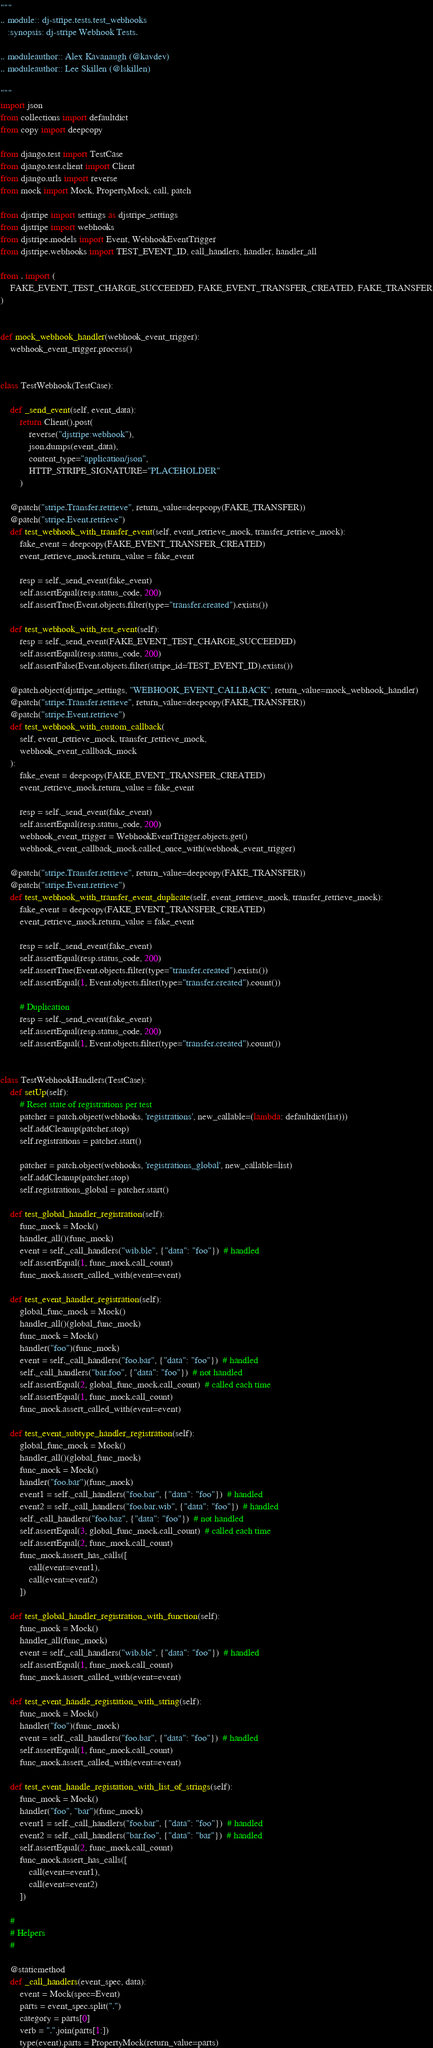Convert code to text. <code><loc_0><loc_0><loc_500><loc_500><_Python_>"""
.. module:: dj-stripe.tests.test_webhooks
   :synopsis: dj-stripe Webhook Tests.

.. moduleauthor:: Alex Kavanaugh (@kavdev)
.. moduleauthor:: Lee Skillen (@lskillen)

"""
import json
from collections import defaultdict
from copy import deepcopy

from django.test import TestCase
from django.test.client import Client
from django.urls import reverse
from mock import Mock, PropertyMock, call, patch

from djstripe import settings as djstripe_settings
from djstripe import webhooks
from djstripe.models import Event, WebhookEventTrigger
from djstripe.webhooks import TEST_EVENT_ID, call_handlers, handler, handler_all

from . import (
    FAKE_EVENT_TEST_CHARGE_SUCCEEDED, FAKE_EVENT_TRANSFER_CREATED, FAKE_TRANSFER
)


def mock_webhook_handler(webhook_event_trigger):
    webhook_event_trigger.process()


class TestWebhook(TestCase):

    def _send_event(self, event_data):
        return Client().post(
            reverse("djstripe:webhook"),
            json.dumps(event_data),
            content_type="application/json",
            HTTP_STRIPE_SIGNATURE="PLACEHOLDER"
        )

    @patch("stripe.Transfer.retrieve", return_value=deepcopy(FAKE_TRANSFER))
    @patch("stripe.Event.retrieve")
    def test_webhook_with_transfer_event(self, event_retrieve_mock, transfer_retrieve_mock):
        fake_event = deepcopy(FAKE_EVENT_TRANSFER_CREATED)
        event_retrieve_mock.return_value = fake_event

        resp = self._send_event(fake_event)
        self.assertEqual(resp.status_code, 200)
        self.assertTrue(Event.objects.filter(type="transfer.created").exists())

    def test_webhook_with_test_event(self):
        resp = self._send_event(FAKE_EVENT_TEST_CHARGE_SUCCEEDED)
        self.assertEqual(resp.status_code, 200)
        self.assertFalse(Event.objects.filter(stripe_id=TEST_EVENT_ID).exists())

    @patch.object(djstripe_settings, "WEBHOOK_EVENT_CALLBACK", return_value=mock_webhook_handler)
    @patch("stripe.Transfer.retrieve", return_value=deepcopy(FAKE_TRANSFER))
    @patch("stripe.Event.retrieve")
    def test_webhook_with_custom_callback(
        self, event_retrieve_mock, transfer_retrieve_mock,
        webhook_event_callback_mock
    ):
        fake_event = deepcopy(FAKE_EVENT_TRANSFER_CREATED)
        event_retrieve_mock.return_value = fake_event

        resp = self._send_event(fake_event)
        self.assertEqual(resp.status_code, 200)
        webhook_event_trigger = WebhookEventTrigger.objects.get()
        webhook_event_callback_mock.called_once_with(webhook_event_trigger)

    @patch("stripe.Transfer.retrieve", return_value=deepcopy(FAKE_TRANSFER))
    @patch("stripe.Event.retrieve")
    def test_webhook_with_transfer_event_duplicate(self, event_retrieve_mock, transfer_retrieve_mock):
        fake_event = deepcopy(FAKE_EVENT_TRANSFER_CREATED)
        event_retrieve_mock.return_value = fake_event

        resp = self._send_event(fake_event)
        self.assertEqual(resp.status_code, 200)
        self.assertTrue(Event.objects.filter(type="transfer.created").exists())
        self.assertEqual(1, Event.objects.filter(type="transfer.created").count())

        # Duplication
        resp = self._send_event(fake_event)
        self.assertEqual(resp.status_code, 200)
        self.assertEqual(1, Event.objects.filter(type="transfer.created").count())


class TestWebhookHandlers(TestCase):
    def setUp(self):
        # Reset state of registrations per test
        patcher = patch.object(webhooks, 'registrations', new_callable=(lambda: defaultdict(list)))
        self.addCleanup(patcher.stop)
        self.registrations = patcher.start()

        patcher = patch.object(webhooks, 'registrations_global', new_callable=list)
        self.addCleanup(patcher.stop)
        self.registrations_global = patcher.start()

    def test_global_handler_registration(self):
        func_mock = Mock()
        handler_all()(func_mock)
        event = self._call_handlers("wib.ble", {"data": "foo"})  # handled
        self.assertEqual(1, func_mock.call_count)
        func_mock.assert_called_with(event=event)

    def test_event_handler_registration(self):
        global_func_mock = Mock()
        handler_all()(global_func_mock)
        func_mock = Mock()
        handler("foo")(func_mock)
        event = self._call_handlers("foo.bar", {"data": "foo"})  # handled
        self._call_handlers("bar.foo", {"data": "foo"})  # not handled
        self.assertEqual(2, global_func_mock.call_count)  # called each time
        self.assertEqual(1, func_mock.call_count)
        func_mock.assert_called_with(event=event)

    def test_event_subtype_handler_registration(self):
        global_func_mock = Mock()
        handler_all()(global_func_mock)
        func_mock = Mock()
        handler("foo.bar")(func_mock)
        event1 = self._call_handlers("foo.bar", {"data": "foo"})  # handled
        event2 = self._call_handlers("foo.bar.wib", {"data": "foo"})  # handled
        self._call_handlers("foo.baz", {"data": "foo"})  # not handled
        self.assertEqual(3, global_func_mock.call_count)  # called each time
        self.assertEqual(2, func_mock.call_count)
        func_mock.assert_has_calls([
            call(event=event1),
            call(event=event2)
        ])

    def test_global_handler_registration_with_function(self):
        func_mock = Mock()
        handler_all(func_mock)
        event = self._call_handlers("wib.ble", {"data": "foo"})  # handled
        self.assertEqual(1, func_mock.call_count)
        func_mock.assert_called_with(event=event)

    def test_event_handle_registation_with_string(self):
        func_mock = Mock()
        handler("foo")(func_mock)
        event = self._call_handlers("foo.bar", {"data": "foo"})  # handled
        self.assertEqual(1, func_mock.call_count)
        func_mock.assert_called_with(event=event)

    def test_event_handle_registation_with_list_of_strings(self):
        func_mock = Mock()
        handler("foo", "bar")(func_mock)
        event1 = self._call_handlers("foo.bar", {"data": "foo"})  # handled
        event2 = self._call_handlers("bar.foo", {"data": "bar"})  # handled
        self.assertEqual(2, func_mock.call_count)
        func_mock.assert_has_calls([
            call(event=event1),
            call(event=event2)
        ])

    #
    # Helpers
    #

    @staticmethod
    def _call_handlers(event_spec, data):
        event = Mock(spec=Event)
        parts = event_spec.split(".")
        category = parts[0]
        verb = ".".join(parts[1:])
        type(event).parts = PropertyMock(return_value=parts)</code> 